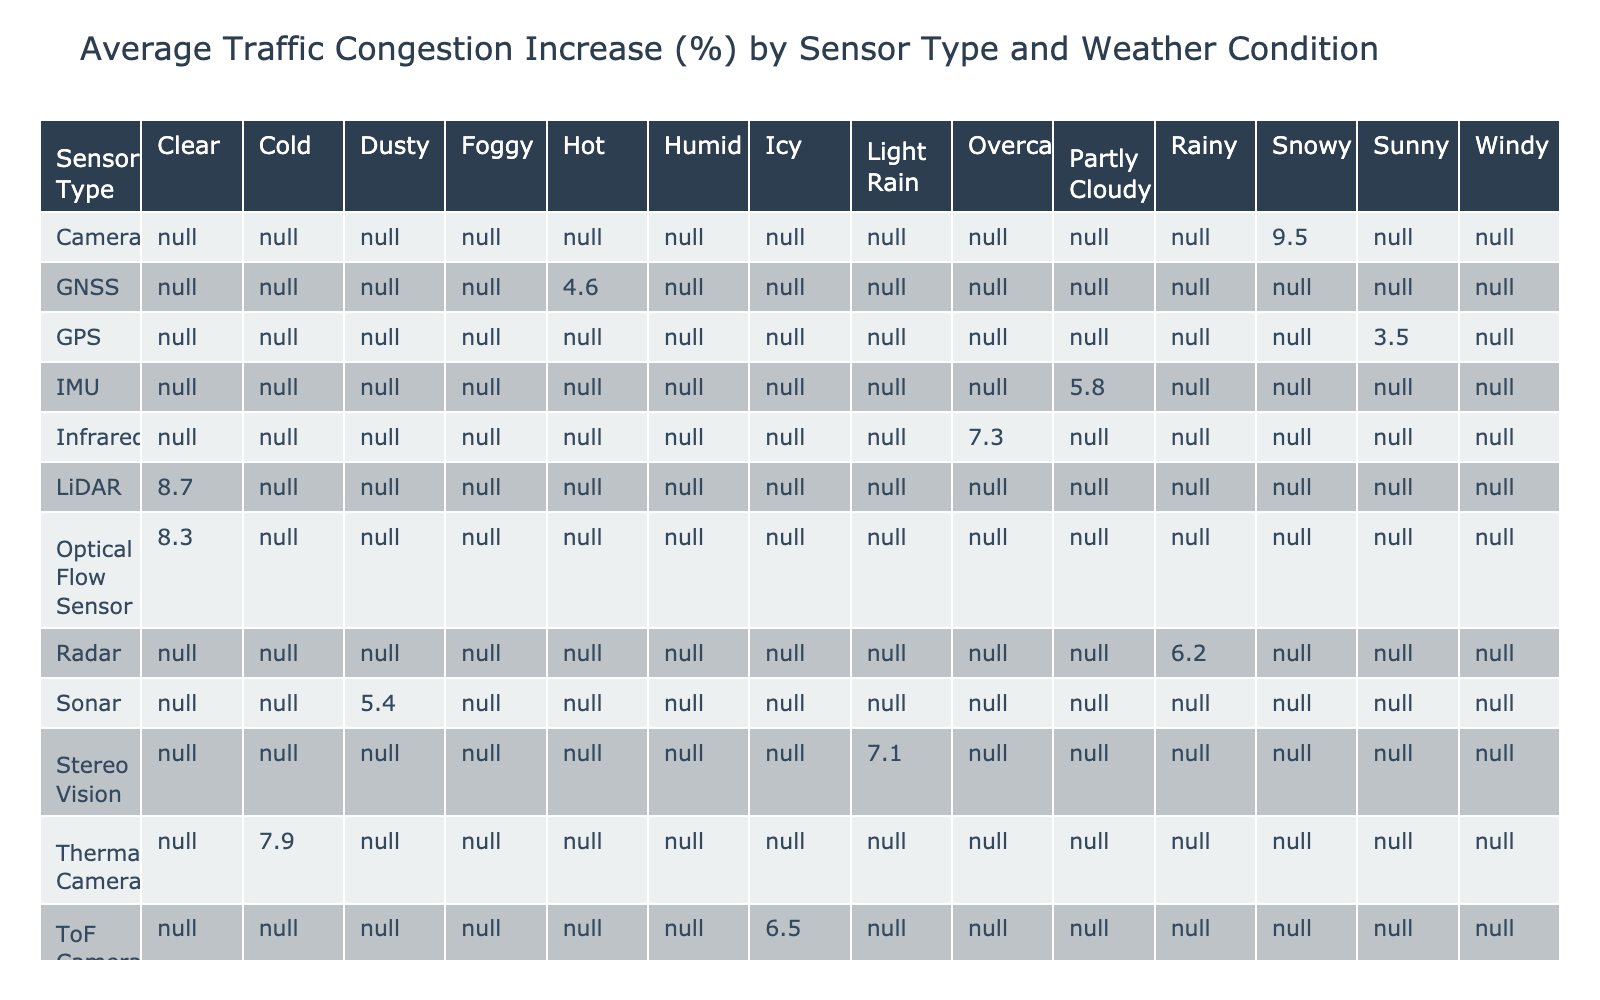What is the highest average traffic congestion increase among sensor types? By inspecting the table, we find that the highest value in the "Traffic Congestion Increase (%)" across all sensor types is 9.5, which is associated with the Camera sensor type.
Answer: 9.5 Which sensor type has the lowest failure rate? Looking at the "Failure Rate (%)" column, the lowest value is 0.7%, which corresponds to the Wheel Encoder sensor type.
Answer: 0.7 Is the average traffic congestion increase for Radar sensors higher in rainy weather compared to clear weather? From the table, we see the average traffic congestion increase for Radar sensors under rainy conditions is 6.2%. However, in clear conditions, since there is no data for Radar, we cannot compare. Thus, it is false to say it is higher in rainy weather.
Answer: No Calculate the average traffic congestion increase for all sensor types during the evening. From the table, the relevant sensor types during the evening are Radar (6.2%), Sonar (5.4%), and V2X Communication (9.1%). Summing these gives 6.2 + 5.4 + 9.1 = 20.7. There are 3 data points, so the average is 20.7/3 = 6.90.
Answer: 6.90 Are there any sensor types that show an increase in traffic congestion greater than 8% during clear weather? The table shows that the Optical Flow Sensor (8.3%) is the only sensor type with a traffic congestion increase greater than 8% in clear weather conditions.
Answer: Yes What is the average failure rate of ultrasonic and thermal camera sensors? First, extract the failure rates: Ultrasonic has 1.2% and Thermal Camera has 2.3%. The sum equals 1.2 + 2.3 = 3.5. There are 2 sensor types, so the average is 3.5/2 = 1.75%.
Answer: 1.75 Which weather condition is associated with the highest average traffic congestion increase? From the table, we will calculate the average congestion increase for each weather condition by taking the average of the respective values. The weather conditions and their sums are: Clear (8.3), Rainy (6.2), Snowy (9.5), Foggy (4.1), Sunny (3.5), Overcast (7.3), Partly Cloudy (5.8), Humid (9.1), Windy (2.9), Hot (4.6), Cold (7.9), and Dusty (5.4), resulting in averages variously. The highest is in Snowy with an average increase of 9.5%.
Answer: Snowy What percentage increase in traffic congestion is seen with GPS failing? The "Traffic Congestion Increase (%)" associated with GPS sensor failures is indicated as 3.5%.
Answer: 3.5 Are there any sensor types that resulted in an increase in traffic congestion of less than 5%? From the table, we see the Wheel Encoder (2.9%) and Ultrasonic (4.1%) both have values below 5%. Therefore, there are indeed sensor types with increases below that threshold.
Answer: Yes 